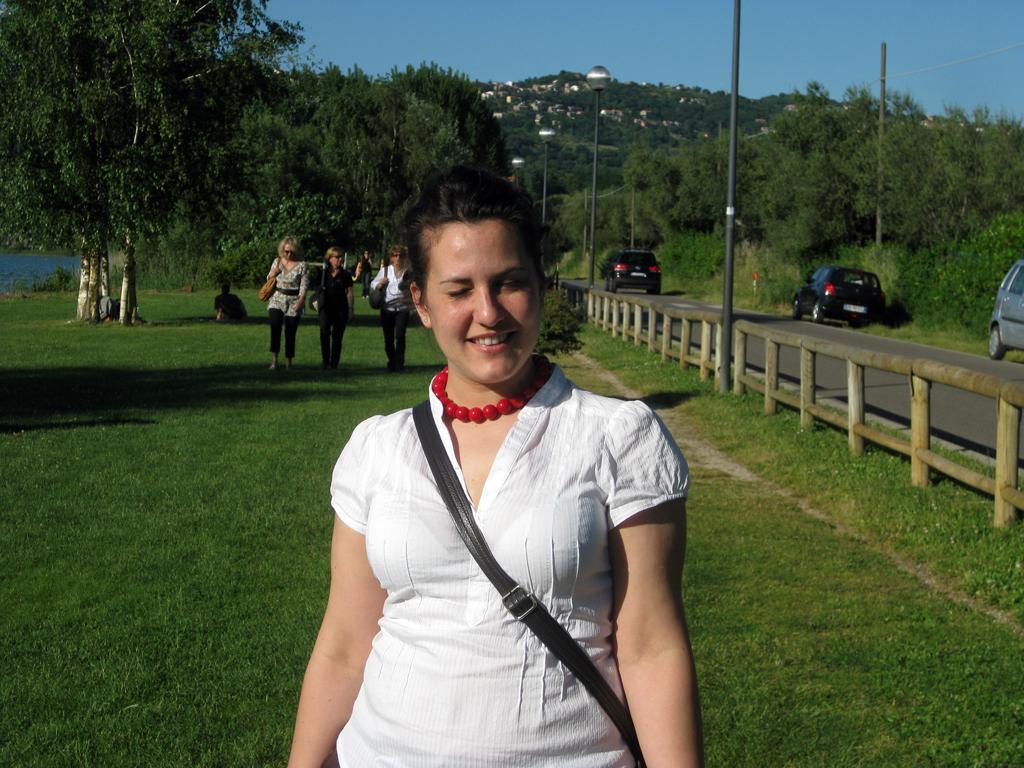Can you describe this image briefly? In the center of the image there is a lady wearing white color shirt and black color bag. At the background of the image there are trees. There are people walking. At the bottom of the image there is grass. At the right side of the image there is road and there are cars. There are light poles. 